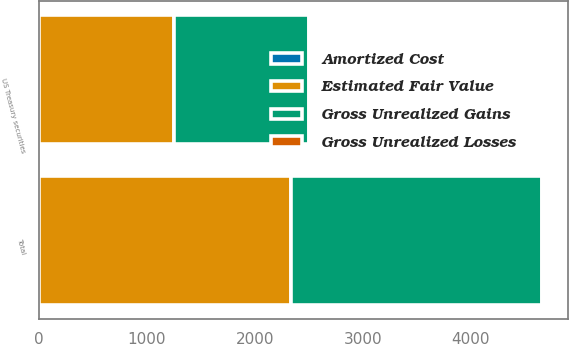Convert chart. <chart><loc_0><loc_0><loc_500><loc_500><stacked_bar_chart><ecel><fcel>US Treasury securities<fcel>Total<nl><fcel>Gross Unrealized Gains<fcel>1250<fcel>2331<nl><fcel>Gross Unrealized Losses<fcel>1<fcel>3<nl><fcel>Amortized Cost<fcel>1<fcel>1<nl><fcel>Estimated Fair Value<fcel>1250<fcel>2329<nl></chart> 